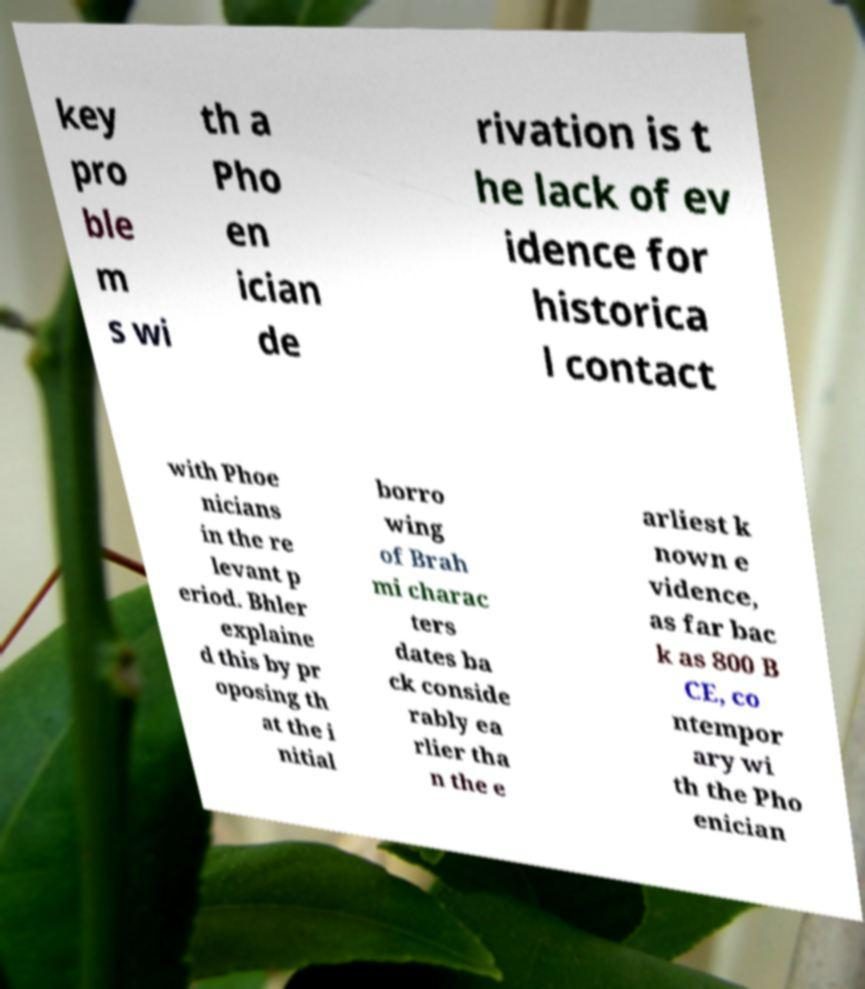Can you read and provide the text displayed in the image?This photo seems to have some interesting text. Can you extract and type it out for me? key pro ble m s wi th a Pho en ician de rivation is t he lack of ev idence for historica l contact with Phoe nicians in the re levant p eriod. Bhler explaine d this by pr oposing th at the i nitial borro wing of Brah mi charac ters dates ba ck conside rably ea rlier tha n the e arliest k nown e vidence, as far bac k as 800 B CE, co ntempor ary wi th the Pho enician 